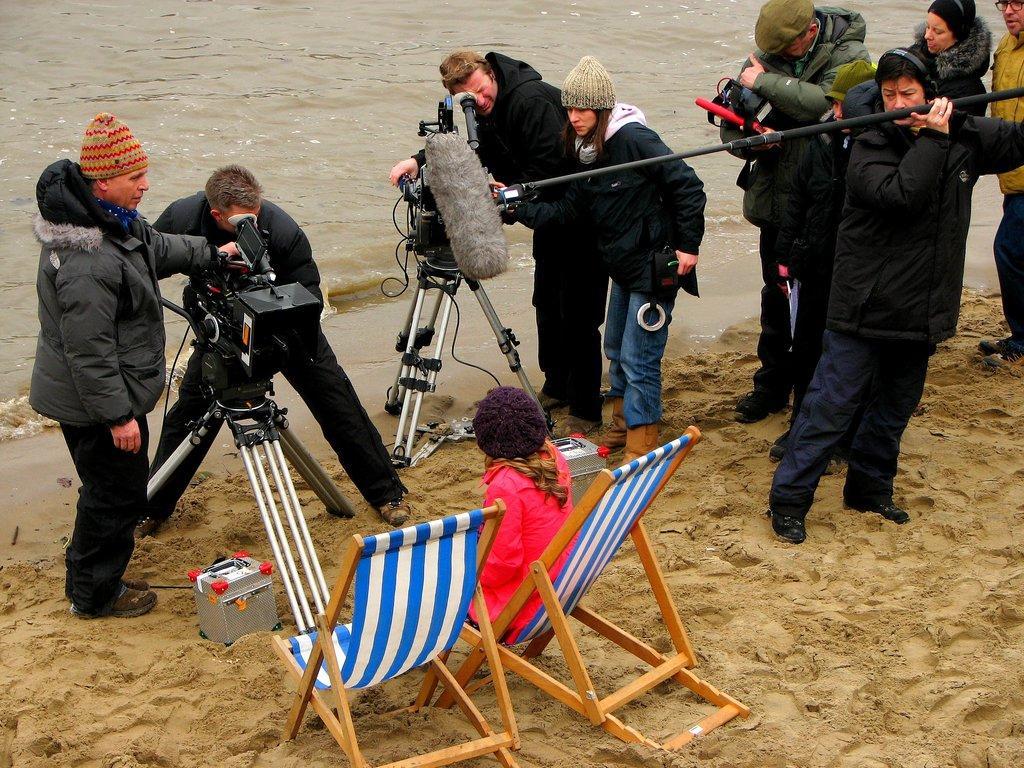How would you summarize this image in a sentence or two? This picture describes about group of people in they are all standing except one woman she is seated in the chair and a man is trying to capture her with camera and we can see some water. 